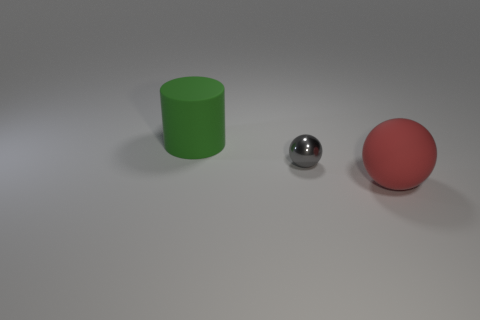Is there anything else that has the same color as the big matte ball? No, there are no other objects in the image that share the same color as the large red matte ball. The small shiny sphere is silver, and the cylinder is green, both of which are distinct from the ball's red hue. 